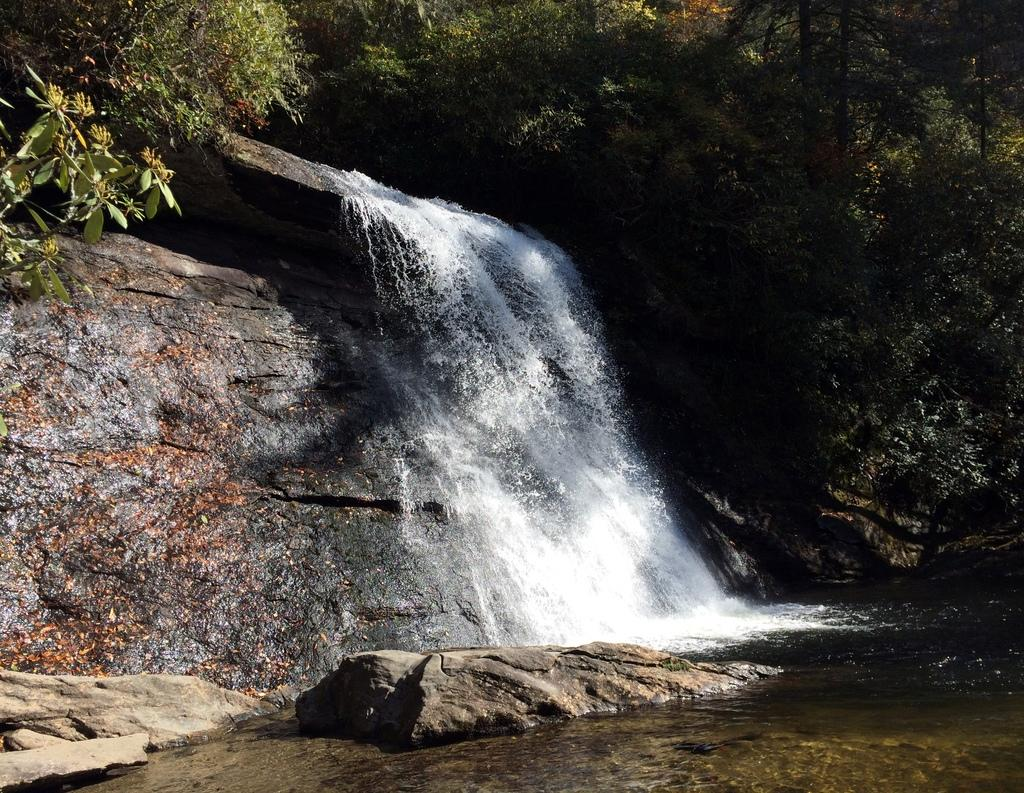What type of natural features can be seen in the image? There are trees, a waterfall, rocks, and a mountain in the image. What might be the source of the waterfall in the image? The waterfall might be sourced from the mountain or a higher elevation in the image. Can you describe the time of day when the image was likely taken? The image was likely taken during the day, as there is sufficient light to see the details of the landscape. What type of dolls can be seen hanging from the icicles in the image? There are no dolls or icicles present in the image; it features a landscape with trees, a waterfall, rocks, and a mountain. 